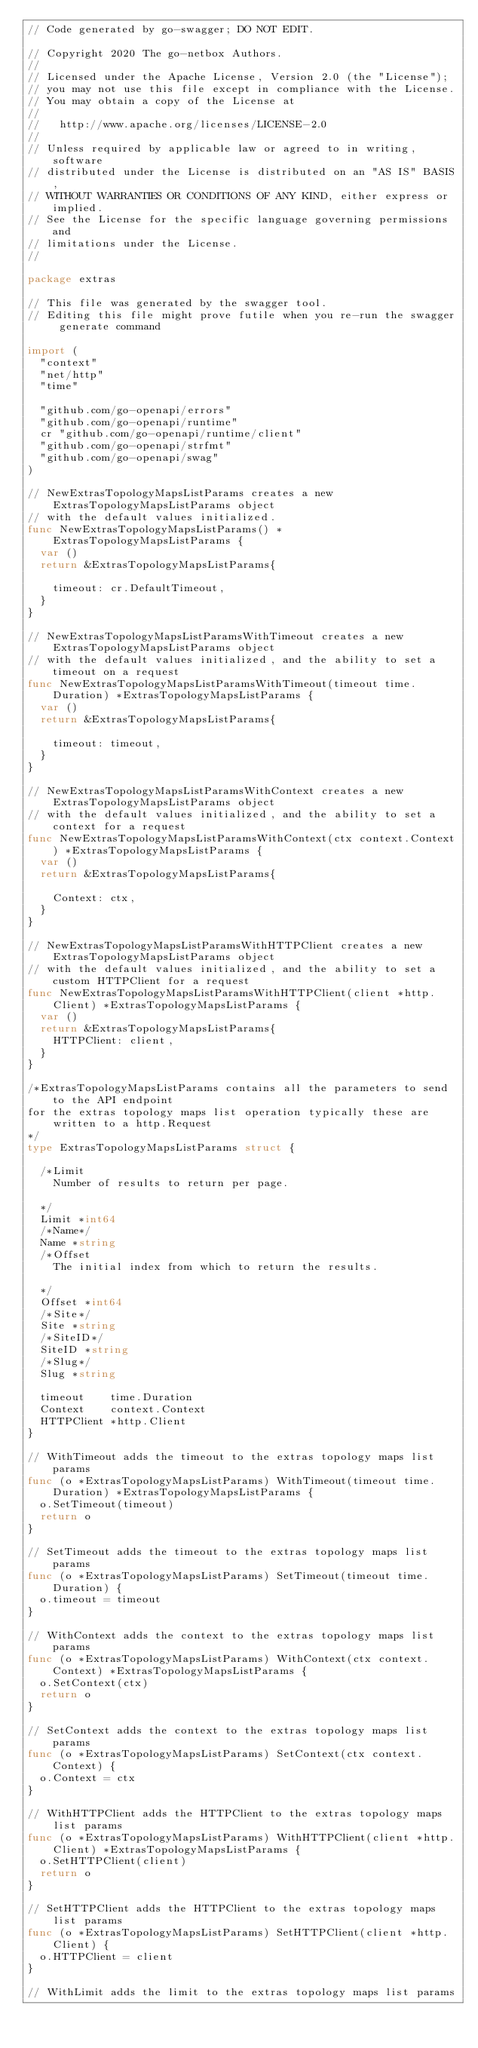Convert code to text. <code><loc_0><loc_0><loc_500><loc_500><_Go_>// Code generated by go-swagger; DO NOT EDIT.

// Copyright 2020 The go-netbox Authors.
//
// Licensed under the Apache License, Version 2.0 (the "License");
// you may not use this file except in compliance with the License.
// You may obtain a copy of the License at
//
//   http://www.apache.org/licenses/LICENSE-2.0
//
// Unless required by applicable law or agreed to in writing, software
// distributed under the License is distributed on an "AS IS" BASIS,
// WITHOUT WARRANTIES OR CONDITIONS OF ANY KIND, either express or implied.
// See the License for the specific language governing permissions and
// limitations under the License.
//

package extras

// This file was generated by the swagger tool.
// Editing this file might prove futile when you re-run the swagger generate command

import (
	"context"
	"net/http"
	"time"

	"github.com/go-openapi/errors"
	"github.com/go-openapi/runtime"
	cr "github.com/go-openapi/runtime/client"
	"github.com/go-openapi/strfmt"
	"github.com/go-openapi/swag"
)

// NewExtrasTopologyMapsListParams creates a new ExtrasTopologyMapsListParams object
// with the default values initialized.
func NewExtrasTopologyMapsListParams() *ExtrasTopologyMapsListParams {
	var ()
	return &ExtrasTopologyMapsListParams{

		timeout: cr.DefaultTimeout,
	}
}

// NewExtrasTopologyMapsListParamsWithTimeout creates a new ExtrasTopologyMapsListParams object
// with the default values initialized, and the ability to set a timeout on a request
func NewExtrasTopologyMapsListParamsWithTimeout(timeout time.Duration) *ExtrasTopologyMapsListParams {
	var ()
	return &ExtrasTopologyMapsListParams{

		timeout: timeout,
	}
}

// NewExtrasTopologyMapsListParamsWithContext creates a new ExtrasTopologyMapsListParams object
// with the default values initialized, and the ability to set a context for a request
func NewExtrasTopologyMapsListParamsWithContext(ctx context.Context) *ExtrasTopologyMapsListParams {
	var ()
	return &ExtrasTopologyMapsListParams{

		Context: ctx,
	}
}

// NewExtrasTopologyMapsListParamsWithHTTPClient creates a new ExtrasTopologyMapsListParams object
// with the default values initialized, and the ability to set a custom HTTPClient for a request
func NewExtrasTopologyMapsListParamsWithHTTPClient(client *http.Client) *ExtrasTopologyMapsListParams {
	var ()
	return &ExtrasTopologyMapsListParams{
		HTTPClient: client,
	}
}

/*ExtrasTopologyMapsListParams contains all the parameters to send to the API endpoint
for the extras topology maps list operation typically these are written to a http.Request
*/
type ExtrasTopologyMapsListParams struct {

	/*Limit
	  Number of results to return per page.

	*/
	Limit *int64
	/*Name*/
	Name *string
	/*Offset
	  The initial index from which to return the results.

	*/
	Offset *int64
	/*Site*/
	Site *string
	/*SiteID*/
	SiteID *string
	/*Slug*/
	Slug *string

	timeout    time.Duration
	Context    context.Context
	HTTPClient *http.Client
}

// WithTimeout adds the timeout to the extras topology maps list params
func (o *ExtrasTopologyMapsListParams) WithTimeout(timeout time.Duration) *ExtrasTopologyMapsListParams {
	o.SetTimeout(timeout)
	return o
}

// SetTimeout adds the timeout to the extras topology maps list params
func (o *ExtrasTopologyMapsListParams) SetTimeout(timeout time.Duration) {
	o.timeout = timeout
}

// WithContext adds the context to the extras topology maps list params
func (o *ExtrasTopologyMapsListParams) WithContext(ctx context.Context) *ExtrasTopologyMapsListParams {
	o.SetContext(ctx)
	return o
}

// SetContext adds the context to the extras topology maps list params
func (o *ExtrasTopologyMapsListParams) SetContext(ctx context.Context) {
	o.Context = ctx
}

// WithHTTPClient adds the HTTPClient to the extras topology maps list params
func (o *ExtrasTopologyMapsListParams) WithHTTPClient(client *http.Client) *ExtrasTopologyMapsListParams {
	o.SetHTTPClient(client)
	return o
}

// SetHTTPClient adds the HTTPClient to the extras topology maps list params
func (o *ExtrasTopologyMapsListParams) SetHTTPClient(client *http.Client) {
	o.HTTPClient = client
}

// WithLimit adds the limit to the extras topology maps list params</code> 